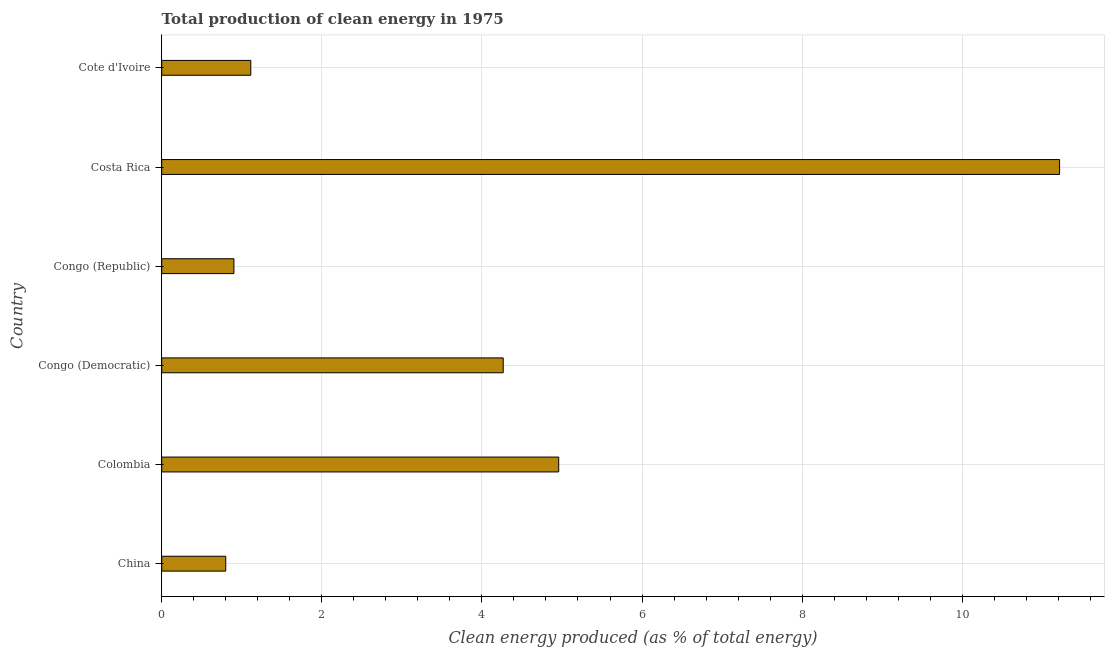What is the title of the graph?
Keep it short and to the point. Total production of clean energy in 1975. What is the label or title of the X-axis?
Provide a succinct answer. Clean energy produced (as % of total energy). What is the label or title of the Y-axis?
Make the answer very short. Country. What is the production of clean energy in Congo (Republic)?
Give a very brief answer. 0.9. Across all countries, what is the maximum production of clean energy?
Make the answer very short. 11.22. Across all countries, what is the minimum production of clean energy?
Provide a succinct answer. 0.8. In which country was the production of clean energy maximum?
Your response must be concise. Costa Rica. What is the sum of the production of clean energy?
Provide a short and direct response. 23.26. What is the difference between the production of clean energy in Congo (Republic) and Costa Rica?
Your response must be concise. -10.31. What is the average production of clean energy per country?
Offer a terse response. 3.88. What is the median production of clean energy?
Your answer should be compact. 2.69. In how many countries, is the production of clean energy greater than 8.4 %?
Provide a succinct answer. 1. What is the ratio of the production of clean energy in Colombia to that in Costa Rica?
Keep it short and to the point. 0.44. Is the production of clean energy in Congo (Democratic) less than that in Cote d'Ivoire?
Provide a succinct answer. No. What is the difference between the highest and the second highest production of clean energy?
Provide a short and direct response. 6.26. Is the sum of the production of clean energy in Congo (Democratic) and Cote d'Ivoire greater than the maximum production of clean energy across all countries?
Provide a succinct answer. No. What is the difference between the highest and the lowest production of clean energy?
Provide a succinct answer. 10.42. In how many countries, is the production of clean energy greater than the average production of clean energy taken over all countries?
Offer a very short reply. 3. Are all the bars in the graph horizontal?
Make the answer very short. Yes. What is the Clean energy produced (as % of total energy) of China?
Provide a succinct answer. 0.8. What is the Clean energy produced (as % of total energy) in Colombia?
Your answer should be very brief. 4.96. What is the Clean energy produced (as % of total energy) in Congo (Democratic)?
Your response must be concise. 4.27. What is the Clean energy produced (as % of total energy) in Congo (Republic)?
Your response must be concise. 0.9. What is the Clean energy produced (as % of total energy) of Costa Rica?
Your answer should be very brief. 11.22. What is the Clean energy produced (as % of total energy) in Cote d'Ivoire?
Give a very brief answer. 1.11. What is the difference between the Clean energy produced (as % of total energy) in China and Colombia?
Your answer should be compact. -4.16. What is the difference between the Clean energy produced (as % of total energy) in China and Congo (Democratic)?
Offer a very short reply. -3.47. What is the difference between the Clean energy produced (as % of total energy) in China and Congo (Republic)?
Ensure brevity in your answer.  -0.1. What is the difference between the Clean energy produced (as % of total energy) in China and Costa Rica?
Offer a terse response. -10.42. What is the difference between the Clean energy produced (as % of total energy) in China and Cote d'Ivoire?
Give a very brief answer. -0.31. What is the difference between the Clean energy produced (as % of total energy) in Colombia and Congo (Democratic)?
Your answer should be very brief. 0.69. What is the difference between the Clean energy produced (as % of total energy) in Colombia and Congo (Republic)?
Offer a terse response. 4.06. What is the difference between the Clean energy produced (as % of total energy) in Colombia and Costa Rica?
Keep it short and to the point. -6.26. What is the difference between the Clean energy produced (as % of total energy) in Colombia and Cote d'Ivoire?
Provide a short and direct response. 3.85. What is the difference between the Clean energy produced (as % of total energy) in Congo (Democratic) and Congo (Republic)?
Your response must be concise. 3.36. What is the difference between the Clean energy produced (as % of total energy) in Congo (Democratic) and Costa Rica?
Offer a terse response. -6.95. What is the difference between the Clean energy produced (as % of total energy) in Congo (Democratic) and Cote d'Ivoire?
Your answer should be compact. 3.15. What is the difference between the Clean energy produced (as % of total energy) in Congo (Republic) and Costa Rica?
Offer a very short reply. -10.31. What is the difference between the Clean energy produced (as % of total energy) in Congo (Republic) and Cote d'Ivoire?
Offer a very short reply. -0.21. What is the difference between the Clean energy produced (as % of total energy) in Costa Rica and Cote d'Ivoire?
Your answer should be compact. 10.1. What is the ratio of the Clean energy produced (as % of total energy) in China to that in Colombia?
Ensure brevity in your answer.  0.16. What is the ratio of the Clean energy produced (as % of total energy) in China to that in Congo (Democratic)?
Offer a very short reply. 0.19. What is the ratio of the Clean energy produced (as % of total energy) in China to that in Congo (Republic)?
Ensure brevity in your answer.  0.89. What is the ratio of the Clean energy produced (as % of total energy) in China to that in Costa Rica?
Your answer should be compact. 0.07. What is the ratio of the Clean energy produced (as % of total energy) in China to that in Cote d'Ivoire?
Your response must be concise. 0.72. What is the ratio of the Clean energy produced (as % of total energy) in Colombia to that in Congo (Democratic)?
Provide a short and direct response. 1.16. What is the ratio of the Clean energy produced (as % of total energy) in Colombia to that in Congo (Republic)?
Keep it short and to the point. 5.5. What is the ratio of the Clean energy produced (as % of total energy) in Colombia to that in Costa Rica?
Make the answer very short. 0.44. What is the ratio of the Clean energy produced (as % of total energy) in Colombia to that in Cote d'Ivoire?
Your answer should be compact. 4.46. What is the ratio of the Clean energy produced (as % of total energy) in Congo (Democratic) to that in Congo (Republic)?
Keep it short and to the point. 4.73. What is the ratio of the Clean energy produced (as % of total energy) in Congo (Democratic) to that in Costa Rica?
Your answer should be very brief. 0.38. What is the ratio of the Clean energy produced (as % of total energy) in Congo (Democratic) to that in Cote d'Ivoire?
Your response must be concise. 3.83. What is the ratio of the Clean energy produced (as % of total energy) in Congo (Republic) to that in Costa Rica?
Give a very brief answer. 0.08. What is the ratio of the Clean energy produced (as % of total energy) in Congo (Republic) to that in Cote d'Ivoire?
Make the answer very short. 0.81. What is the ratio of the Clean energy produced (as % of total energy) in Costa Rica to that in Cote d'Ivoire?
Offer a very short reply. 10.08. 